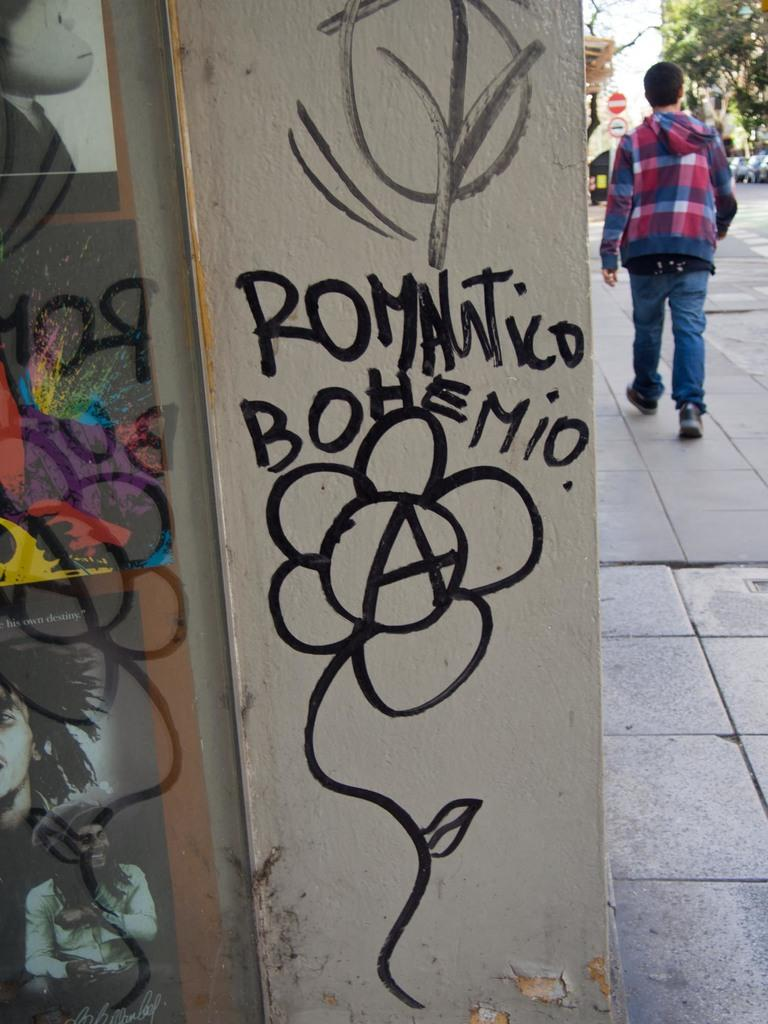Where was the image taken? The image was clicked outside. What is happening on the right side of the image? There is a person walking on the right side of the image. What can be seen in the top right corner of the image? There is a tree in the top right corner of the image. What is written on a wall in the image? There is something written on a wall in the middle of the image. What grade did the person in the image receive for their performance? There is no indication of a person's performance or grade in the image. Can you tell me how the person in the image started their journey? The image does not show the beginning of the person's journey, only that they are walking on the right side. 